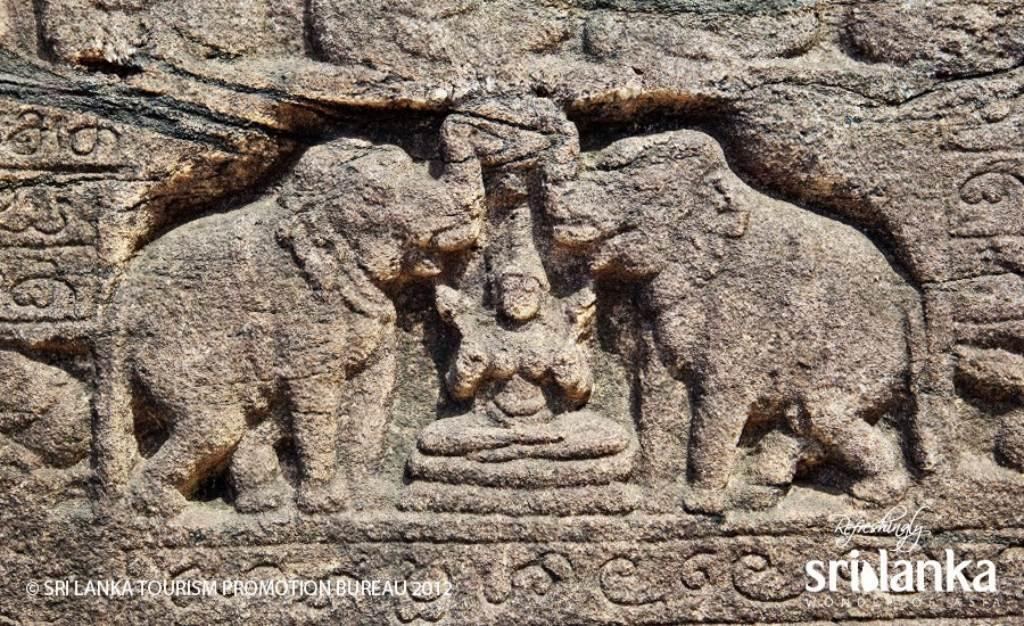What type of structure is shown in the image? There is a historical building in the image. What part of the building is visible? The building's wall is visible. What is depicted on the wall of the building? There is a goddess and two elephants designed on the wall. What type of wine is being served in the image? There is no wine present in the image; it features a historical building with a wall depicting a goddess and two elephants. How many stomachs does the goddess have in the image? The goddess depicted on the wall does not have any stomachs, as it is a two-dimensional representation. 